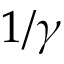<formula> <loc_0><loc_0><loc_500><loc_500>1 / \gamma</formula> 